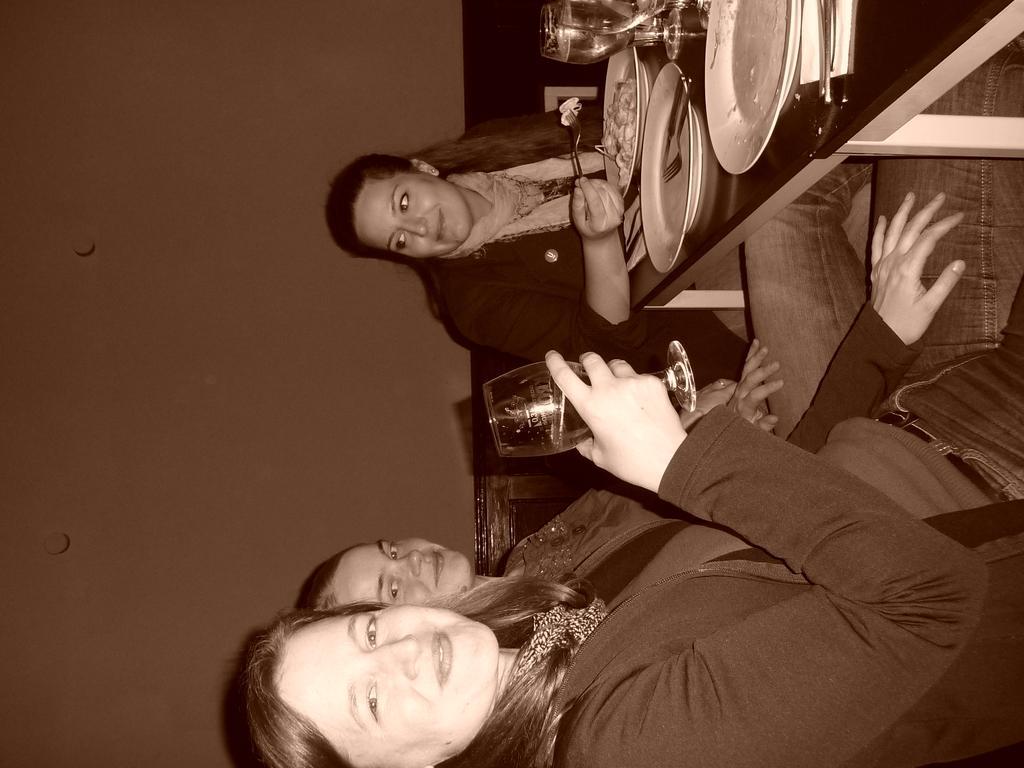How would you summarize this image in a sentence or two? This picture describes about group of people, in the middle of the image we can see a woman, she is smiling and she is holding a glass, in front of them we can see few plates, spoons, glasses and other things on the table. 